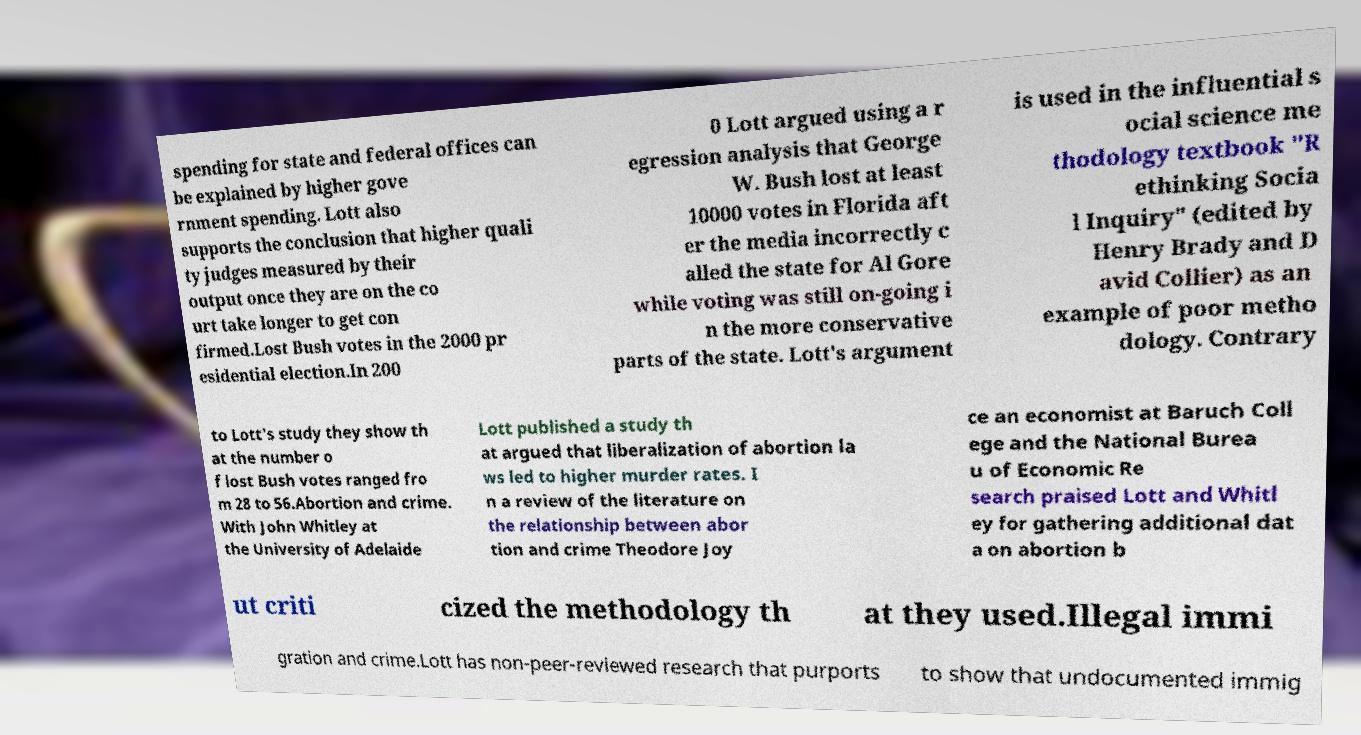Please identify and transcribe the text found in this image. spending for state and federal offices can be explained by higher gove rnment spending. Lott also supports the conclusion that higher quali ty judges measured by their output once they are on the co urt take longer to get con firmed.Lost Bush votes in the 2000 pr esidential election.In 200 0 Lott argued using a r egression analysis that George W. Bush lost at least 10000 votes in Florida aft er the media incorrectly c alled the state for Al Gore while voting was still on-going i n the more conservative parts of the state. Lott's argument is used in the influential s ocial science me thodology textbook "R ethinking Socia l Inquiry" (edited by Henry Brady and D avid Collier) as an example of poor metho dology. Contrary to Lott's study they show th at the number o f lost Bush votes ranged fro m 28 to 56.Abortion and crime. With John Whitley at the University of Adelaide Lott published a study th at argued that liberalization of abortion la ws led to higher murder rates. I n a review of the literature on the relationship between abor tion and crime Theodore Joy ce an economist at Baruch Coll ege and the National Burea u of Economic Re search praised Lott and Whitl ey for gathering additional dat a on abortion b ut criti cized the methodology th at they used.Illegal immi gration and crime.Lott has non-peer-reviewed research that purports to show that undocumented immig 